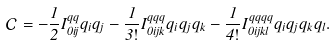<formula> <loc_0><loc_0><loc_500><loc_500>\mathcal { C } = - \frac { 1 } { 2 } I _ { 0 i j } ^ { q q } q _ { i } q _ { j } - \frac { 1 } { 3 ! } I _ { 0 i j k } ^ { q q q } q _ { i } q _ { j } q _ { k } - \frac { 1 } { 4 ! } I _ { 0 i j k l } ^ { q q q q } q _ { i } q _ { j } q _ { k } q _ { l } .</formula> 